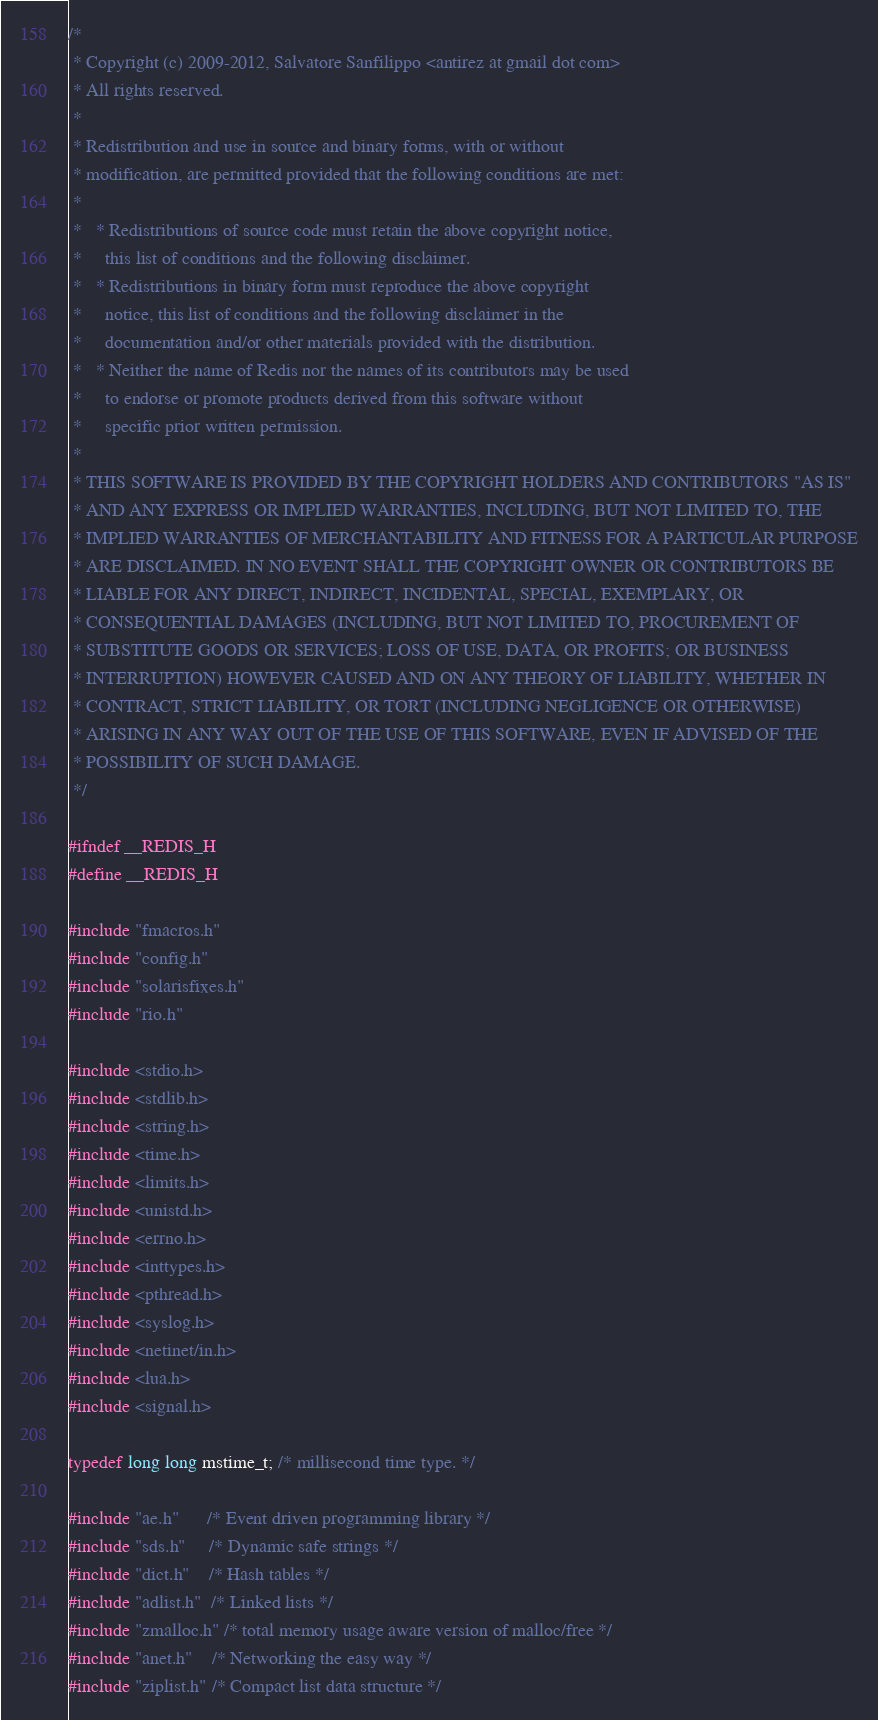<code> <loc_0><loc_0><loc_500><loc_500><_C_>/*
 * Copyright (c) 2009-2012, Salvatore Sanfilippo <antirez at gmail dot com>
 * All rights reserved.
 *
 * Redistribution and use in source and binary forms, with or without
 * modification, are permitted provided that the following conditions are met:
 *
 *   * Redistributions of source code must retain the above copyright notice,
 *     this list of conditions and the following disclaimer.
 *   * Redistributions in binary form must reproduce the above copyright
 *     notice, this list of conditions and the following disclaimer in the
 *     documentation and/or other materials provided with the distribution.
 *   * Neither the name of Redis nor the names of its contributors may be used
 *     to endorse or promote products derived from this software without
 *     specific prior written permission.
 *
 * THIS SOFTWARE IS PROVIDED BY THE COPYRIGHT HOLDERS AND CONTRIBUTORS "AS IS"
 * AND ANY EXPRESS OR IMPLIED WARRANTIES, INCLUDING, BUT NOT LIMITED TO, THE
 * IMPLIED WARRANTIES OF MERCHANTABILITY AND FITNESS FOR A PARTICULAR PURPOSE
 * ARE DISCLAIMED. IN NO EVENT SHALL THE COPYRIGHT OWNER OR CONTRIBUTORS BE
 * LIABLE FOR ANY DIRECT, INDIRECT, INCIDENTAL, SPECIAL, EXEMPLARY, OR
 * CONSEQUENTIAL DAMAGES (INCLUDING, BUT NOT LIMITED TO, PROCUREMENT OF
 * SUBSTITUTE GOODS OR SERVICES; LOSS OF USE, DATA, OR PROFITS; OR BUSINESS
 * INTERRUPTION) HOWEVER CAUSED AND ON ANY THEORY OF LIABILITY, WHETHER IN
 * CONTRACT, STRICT LIABILITY, OR TORT (INCLUDING NEGLIGENCE OR OTHERWISE)
 * ARISING IN ANY WAY OUT OF THE USE OF THIS SOFTWARE, EVEN IF ADVISED OF THE
 * POSSIBILITY OF SUCH DAMAGE.
 */

#ifndef __REDIS_H
#define __REDIS_H

#include "fmacros.h"
#include "config.h"
#include "solarisfixes.h"
#include "rio.h"

#include <stdio.h>
#include <stdlib.h>
#include <string.h>
#include <time.h>
#include <limits.h>
#include <unistd.h>
#include <errno.h>
#include <inttypes.h>
#include <pthread.h>
#include <syslog.h>
#include <netinet/in.h>
#include <lua.h>
#include <signal.h>

typedef long long mstime_t; /* millisecond time type. */

#include "ae.h"      /* Event driven programming library */
#include "sds.h"     /* Dynamic safe strings */
#include "dict.h"    /* Hash tables */
#include "adlist.h"  /* Linked lists */
#include "zmalloc.h" /* total memory usage aware version of malloc/free */
#include "anet.h"    /* Networking the easy way */
#include "ziplist.h" /* Compact list data structure */</code> 